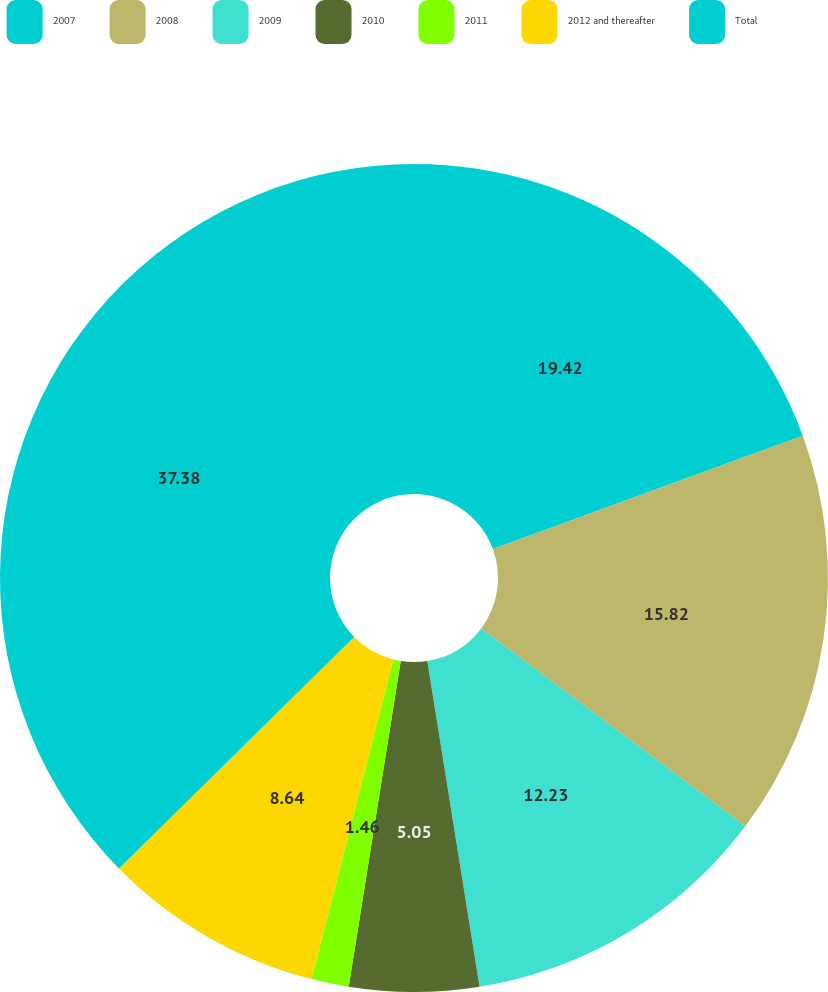<chart> <loc_0><loc_0><loc_500><loc_500><pie_chart><fcel>2007<fcel>2008<fcel>2009<fcel>2010<fcel>2011<fcel>2012 and thereafter<fcel>Total<nl><fcel>19.41%<fcel>15.82%<fcel>12.23%<fcel>5.05%<fcel>1.46%<fcel>8.64%<fcel>37.37%<nl></chart> 